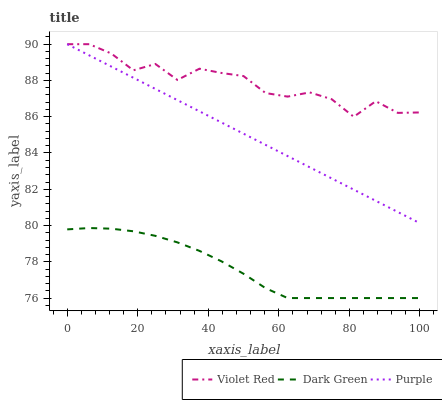Does Dark Green have the minimum area under the curve?
Answer yes or no. Yes. Does Violet Red have the maximum area under the curve?
Answer yes or no. Yes. Does Violet Red have the minimum area under the curve?
Answer yes or no. No. Does Dark Green have the maximum area under the curve?
Answer yes or no. No. Is Purple the smoothest?
Answer yes or no. Yes. Is Violet Red the roughest?
Answer yes or no. Yes. Is Dark Green the smoothest?
Answer yes or no. No. Is Dark Green the roughest?
Answer yes or no. No. Does Dark Green have the lowest value?
Answer yes or no. Yes. Does Violet Red have the lowest value?
Answer yes or no. No. Does Violet Red have the highest value?
Answer yes or no. Yes. Does Dark Green have the highest value?
Answer yes or no. No. Is Dark Green less than Violet Red?
Answer yes or no. Yes. Is Violet Red greater than Dark Green?
Answer yes or no. Yes. Does Purple intersect Violet Red?
Answer yes or no. Yes. Is Purple less than Violet Red?
Answer yes or no. No. Is Purple greater than Violet Red?
Answer yes or no. No. Does Dark Green intersect Violet Red?
Answer yes or no. No. 